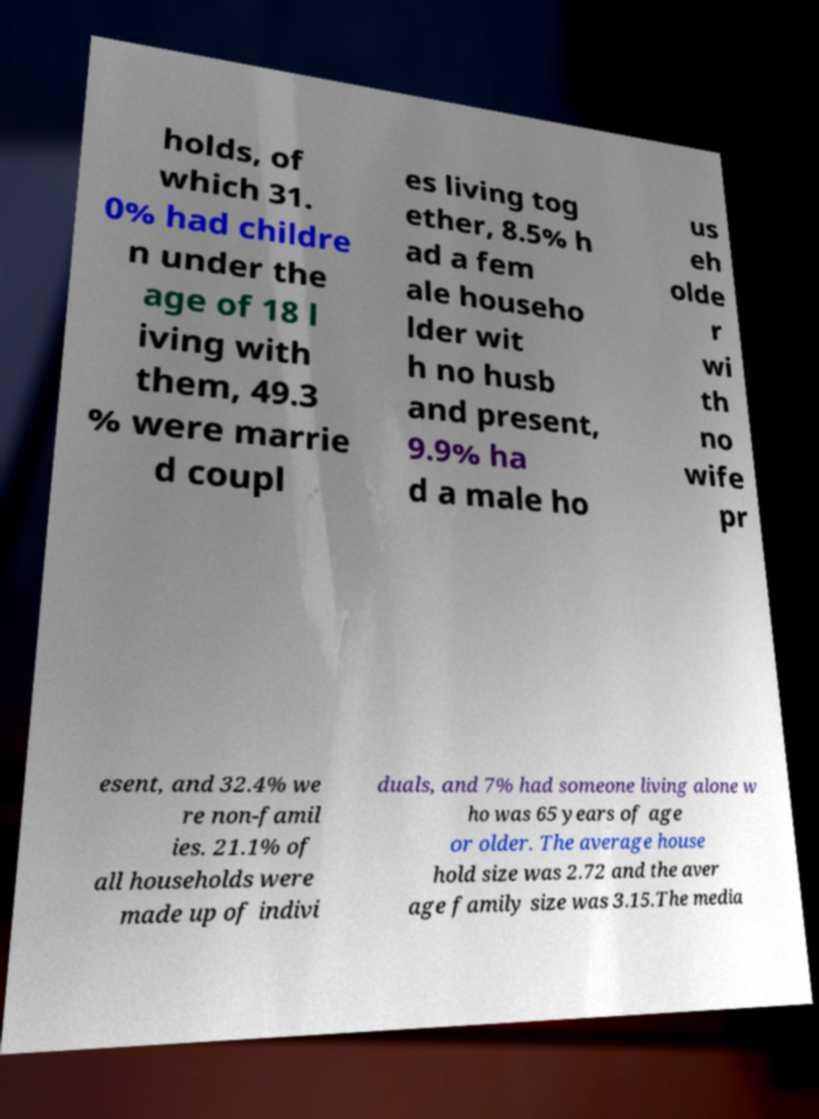Could you extract and type out the text from this image? holds, of which 31. 0% had childre n under the age of 18 l iving with them, 49.3 % were marrie d coupl es living tog ether, 8.5% h ad a fem ale househo lder wit h no husb and present, 9.9% ha d a male ho us eh olde r wi th no wife pr esent, and 32.4% we re non-famil ies. 21.1% of all households were made up of indivi duals, and 7% had someone living alone w ho was 65 years of age or older. The average house hold size was 2.72 and the aver age family size was 3.15.The media 